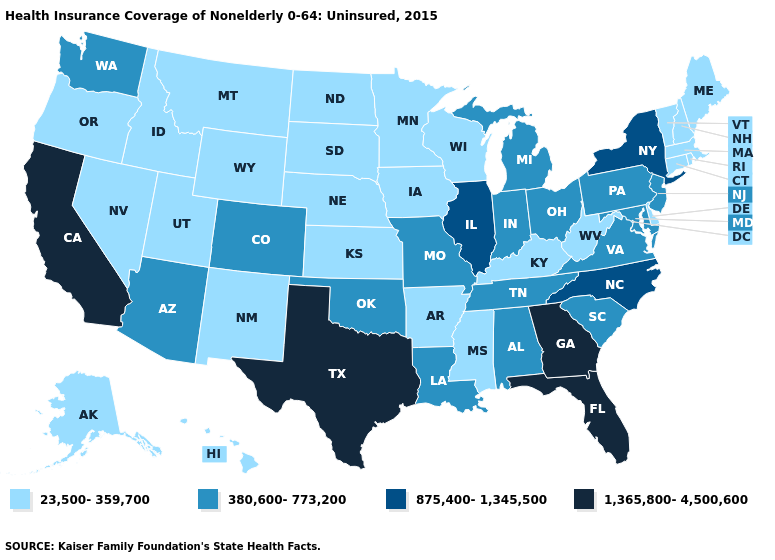Among the states that border North Carolina , does Tennessee have the highest value?
Keep it brief. No. What is the value of Idaho?
Quick response, please. 23,500-359,700. Does Florida have a lower value than Iowa?
Be succinct. No. Name the states that have a value in the range 23,500-359,700?
Give a very brief answer. Alaska, Arkansas, Connecticut, Delaware, Hawaii, Idaho, Iowa, Kansas, Kentucky, Maine, Massachusetts, Minnesota, Mississippi, Montana, Nebraska, Nevada, New Hampshire, New Mexico, North Dakota, Oregon, Rhode Island, South Dakota, Utah, Vermont, West Virginia, Wisconsin, Wyoming. Name the states that have a value in the range 23,500-359,700?
Give a very brief answer. Alaska, Arkansas, Connecticut, Delaware, Hawaii, Idaho, Iowa, Kansas, Kentucky, Maine, Massachusetts, Minnesota, Mississippi, Montana, Nebraska, Nevada, New Hampshire, New Mexico, North Dakota, Oregon, Rhode Island, South Dakota, Utah, Vermont, West Virginia, Wisconsin, Wyoming. Does Ohio have the highest value in the MidWest?
Answer briefly. No. Name the states that have a value in the range 875,400-1,345,500?
Give a very brief answer. Illinois, New York, North Carolina. Does Indiana have a lower value than Florida?
Write a very short answer. Yes. Among the states that border Wyoming , does Colorado have the lowest value?
Write a very short answer. No. Among the states that border Nevada , does Idaho have the lowest value?
Concise answer only. Yes. How many symbols are there in the legend?
Quick response, please. 4. Name the states that have a value in the range 1,365,800-4,500,600?
Give a very brief answer. California, Florida, Georgia, Texas. Name the states that have a value in the range 875,400-1,345,500?
Give a very brief answer. Illinois, New York, North Carolina. What is the value of Massachusetts?
Write a very short answer. 23,500-359,700. What is the value of Louisiana?
Be succinct. 380,600-773,200. 